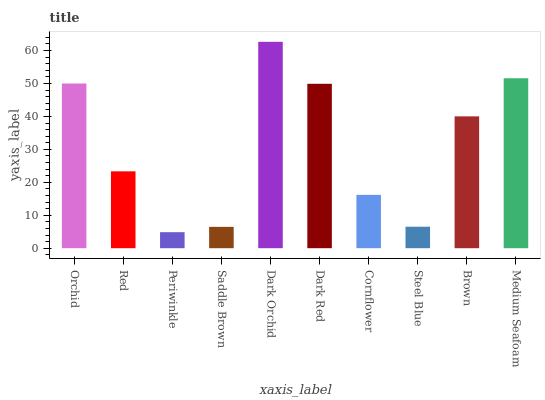Is Periwinkle the minimum?
Answer yes or no. Yes. Is Dark Orchid the maximum?
Answer yes or no. Yes. Is Red the minimum?
Answer yes or no. No. Is Red the maximum?
Answer yes or no. No. Is Orchid greater than Red?
Answer yes or no. Yes. Is Red less than Orchid?
Answer yes or no. Yes. Is Red greater than Orchid?
Answer yes or no. No. Is Orchid less than Red?
Answer yes or no. No. Is Brown the high median?
Answer yes or no. Yes. Is Red the low median?
Answer yes or no. Yes. Is Orchid the high median?
Answer yes or no. No. Is Periwinkle the low median?
Answer yes or no. No. 